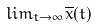Convert formula to latex. <formula><loc_0><loc_0><loc_500><loc_500>l i m _ { t \rightarrow \infty } \overline { x } ( t )</formula> 